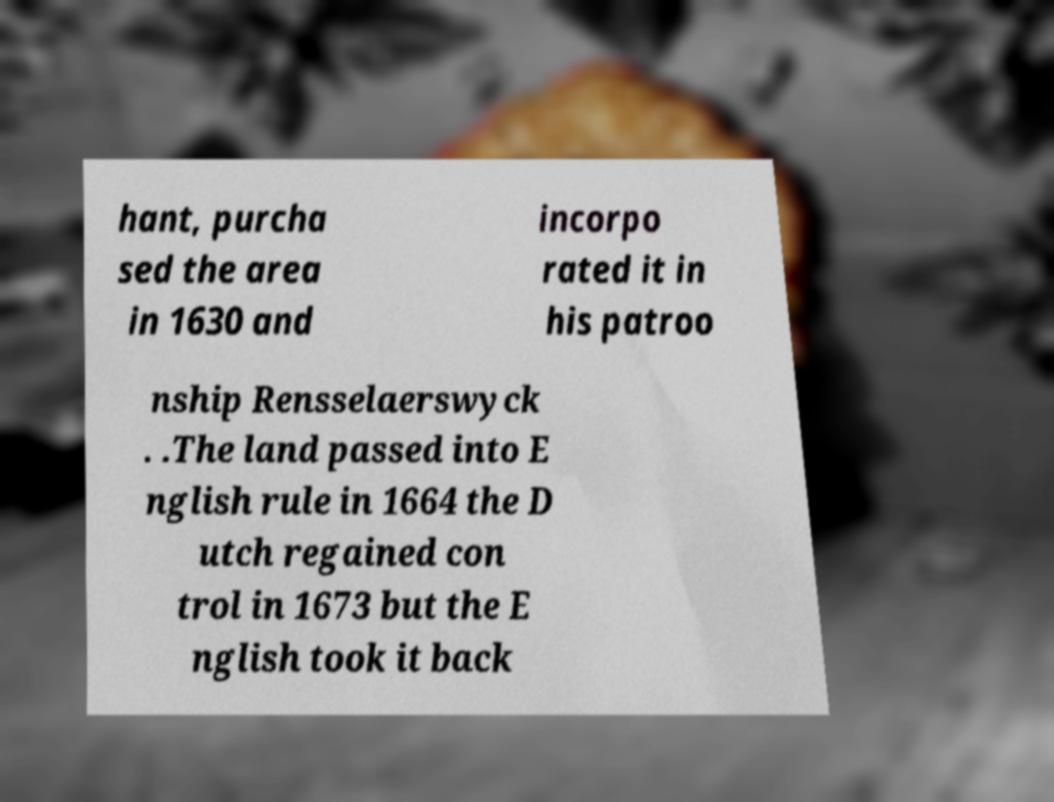Could you assist in decoding the text presented in this image and type it out clearly? hant, purcha sed the area in 1630 and incorpo rated it in his patroo nship Rensselaerswyck . .The land passed into E nglish rule in 1664 the D utch regained con trol in 1673 but the E nglish took it back 